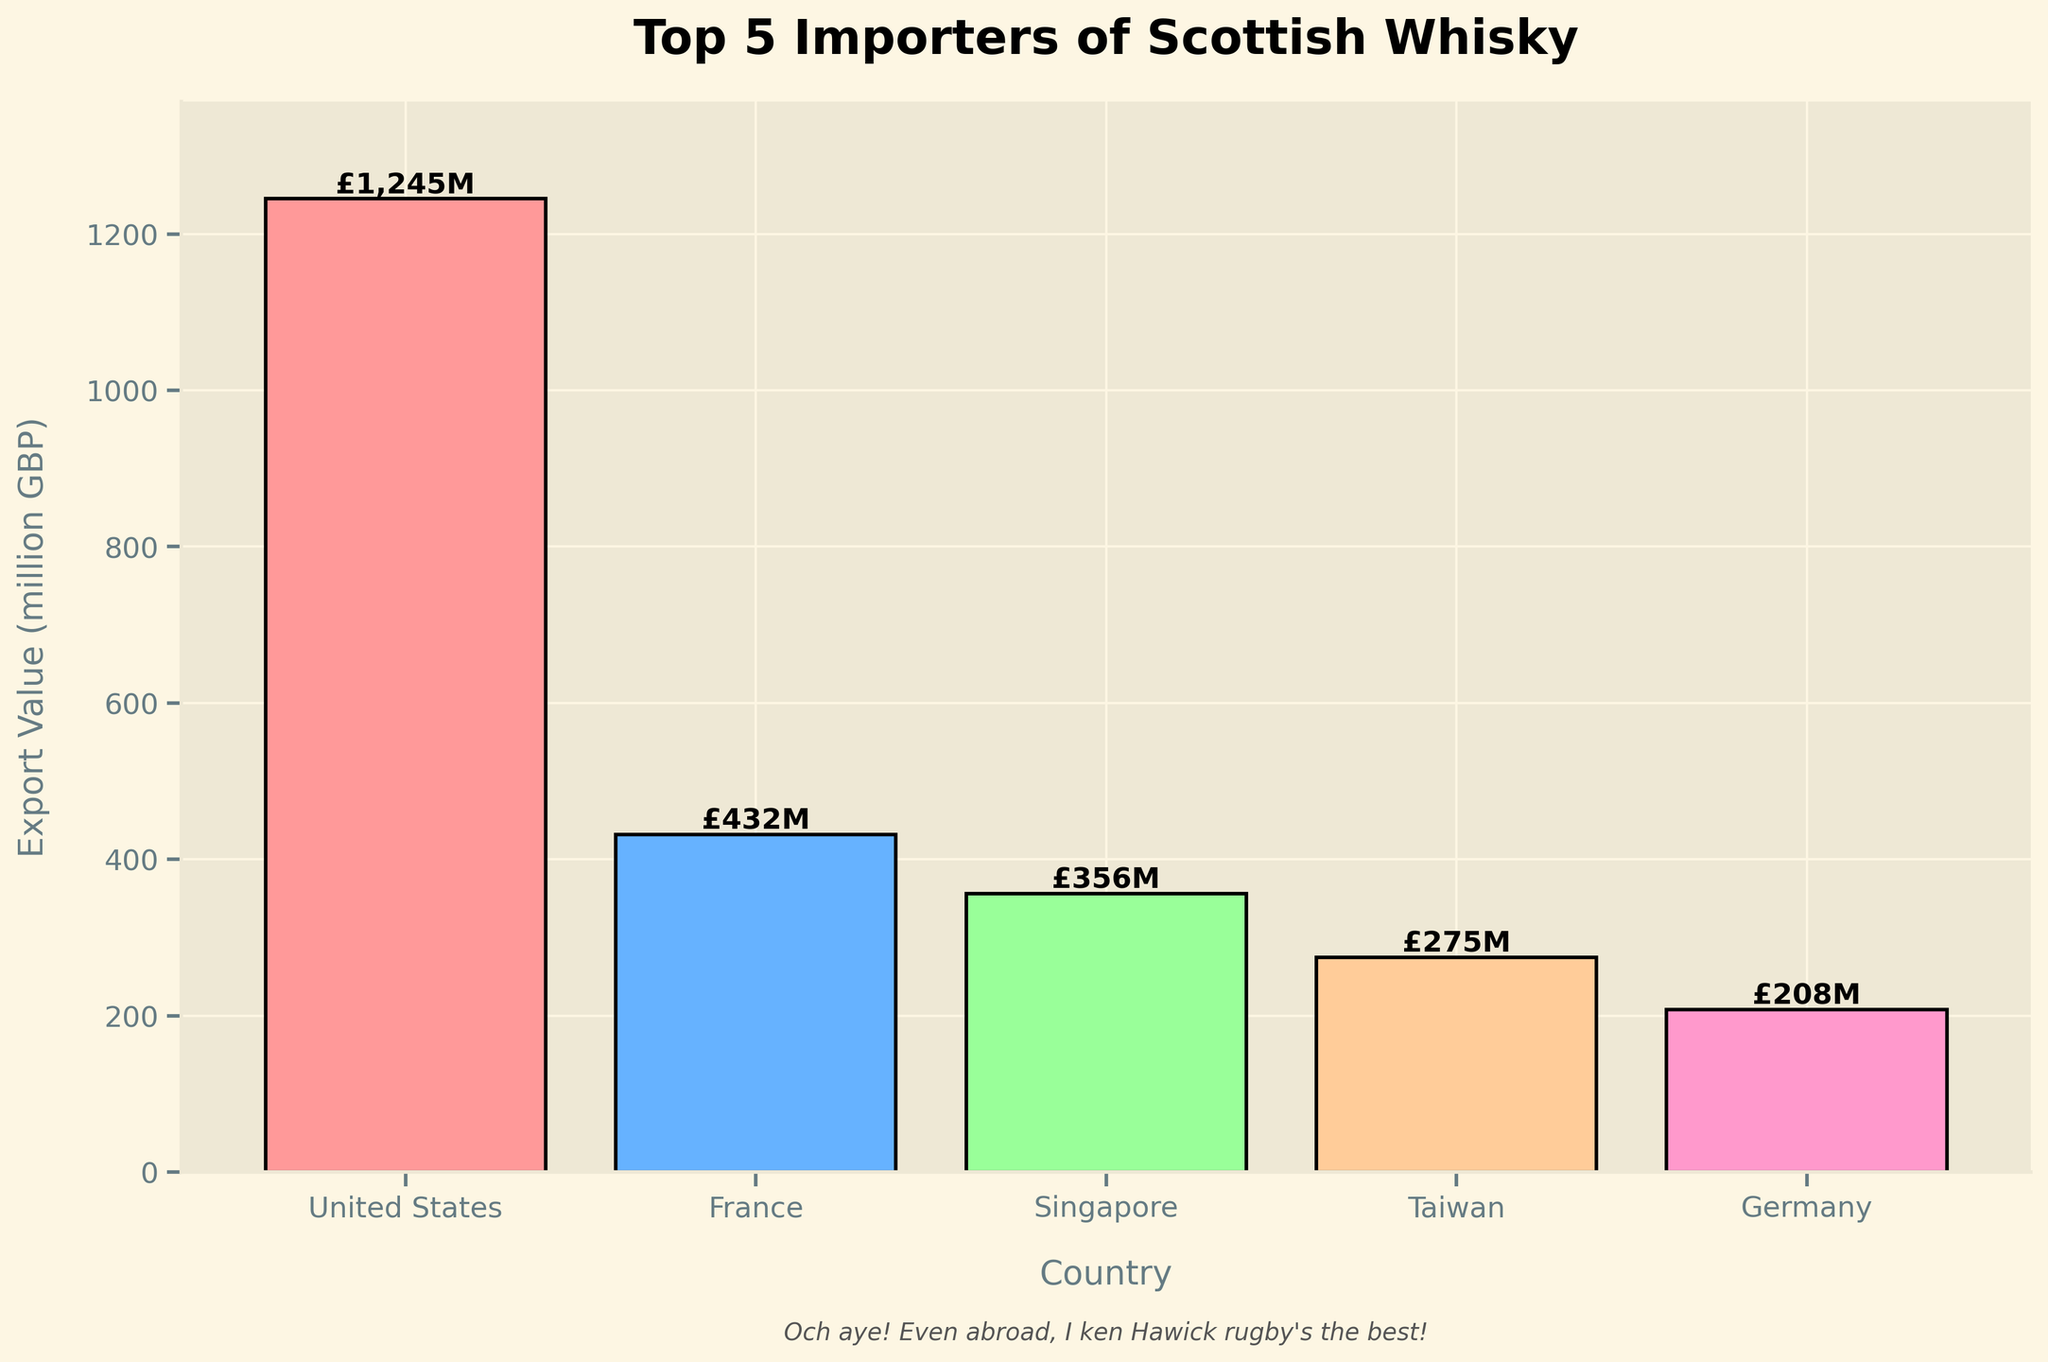What country has the highest export value of Scottish whisky? The bar chart shows the Export Value (million GBP) for each country in the top 5 importers. The tallest bar represents the country with the highest export value. The United States bar is the tallest.
Answer: The United States What is the sum of the export values for the top 3 importers? The export values for the top 3 importers are United States (1245 million GBP), France (432 million GBP), and Singapore (356 million GBP). Adding these values: 1245 + 432 + 356 = 2033 million GBP.
Answer: 2033 million GBP Which country imports more Scottish whisky, Taiwan or Germany? The bar chart shows the export values for the top 5 importers. Taiwan has a value of 275 million GBP while Germany has a value of 208 million GBP.
Answer: Taiwan What is the difference in export value between France and Singapore? The export values are given as France (432 million GBP) and Singapore (356 million GBP). The difference is 432 - 356 = 76 million GBP.
Answer: 76 million GBP How many countries have an export value of over 300 million GBP? The bar chart shows the export values for the top 5 importers. By examining the heights of the bars, you can see that United States, France, and Singapore have values over 300 million GBP.
Answer: 3 Which bar is colored red? From the visual attributes, the bar for the United States is colored red.
Answer: United States What is the average export value for the top 5 importers? The export values for the top 5 importers are United States (1245 million GBP), France (432 million GBP), Singapore (356 million GBP), Taiwan (275 million GBP), and Germany (208 million GBP). Adding these values: 1245 + 432 + 356 + 275 + 208 = 2516 million GBP. Dividing by 5 gives the average: 2516 / 5 = 503.2 million GBP.
Answer: 503.2 million GBP Which country out of the top 5 importers has the smallest export value? The bar chart shows the export values for the top 5 importers, with Germany having the smallest value at 208 million GBP.
Answer: Germany What percentage of the total export value for the top 5 importers is contributed by the United States? The total export value for the top 5 importers is the sum of their individual values: 1245 + 432 + 356 + 275 + 208 = 2516 million GBP. The percentage contributed by the United States is (1245 / 2516) * 100 = 49.47%.
Answer: 49.47% Out of the countries listed, which one imports the least amount of Scottish whisky? The bar chart only shows the top 5 importers. From the data provided, South Africa imports the least with an export value of 43 million GBP.
Answer: South Africa 